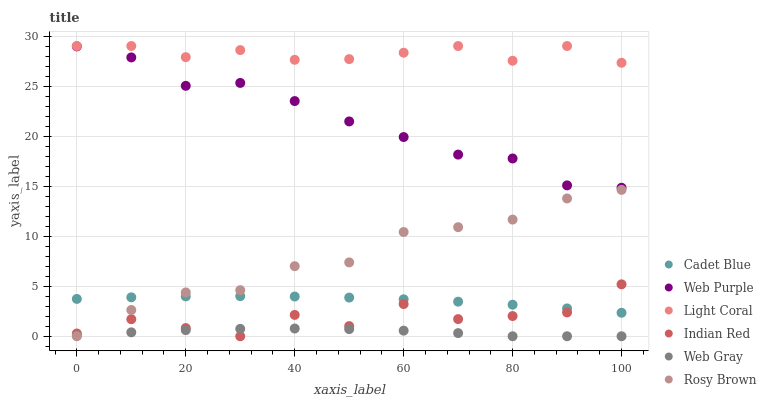Does Web Gray have the minimum area under the curve?
Answer yes or no. Yes. Does Light Coral have the maximum area under the curve?
Answer yes or no. Yes. Does Rosy Brown have the minimum area under the curve?
Answer yes or no. No. Does Rosy Brown have the maximum area under the curve?
Answer yes or no. No. Is Cadet Blue the smoothest?
Answer yes or no. Yes. Is Indian Red the roughest?
Answer yes or no. Yes. Is Rosy Brown the smoothest?
Answer yes or no. No. Is Rosy Brown the roughest?
Answer yes or no. No. Does Rosy Brown have the lowest value?
Answer yes or no. Yes. Does Light Coral have the lowest value?
Answer yes or no. No. Does Light Coral have the highest value?
Answer yes or no. Yes. Does Rosy Brown have the highest value?
Answer yes or no. No. Is Cadet Blue less than Light Coral?
Answer yes or no. Yes. Is Web Purple greater than Indian Red?
Answer yes or no. Yes. Does Cadet Blue intersect Indian Red?
Answer yes or no. Yes. Is Cadet Blue less than Indian Red?
Answer yes or no. No. Is Cadet Blue greater than Indian Red?
Answer yes or no. No. Does Cadet Blue intersect Light Coral?
Answer yes or no. No. 